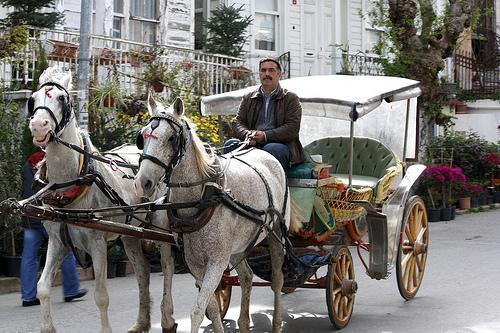How many horses pulling carriage?
Give a very brief answer. 2. How many horses are there?
Give a very brief answer. 2. How many white horses are pulling the carriage?
Give a very brief answer. 2. How many people are walking on the sidewalk?
Give a very brief answer. 1. 